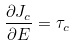<formula> <loc_0><loc_0><loc_500><loc_500>\frac { \partial J _ { c } } { \partial E } = \tau _ { c }</formula> 